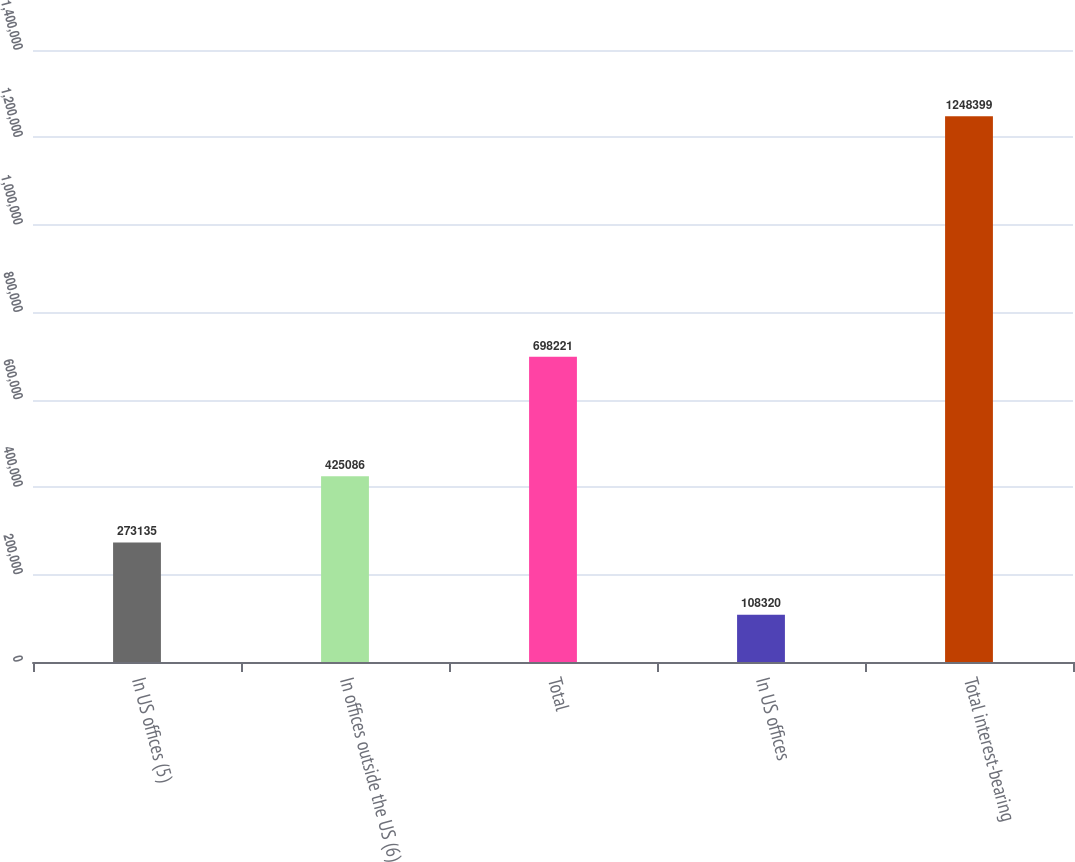<chart> <loc_0><loc_0><loc_500><loc_500><bar_chart><fcel>In US offices (5)<fcel>In offices outside the US (6)<fcel>Total<fcel>In US offices<fcel>Total interest-bearing<nl><fcel>273135<fcel>425086<fcel>698221<fcel>108320<fcel>1.2484e+06<nl></chart> 